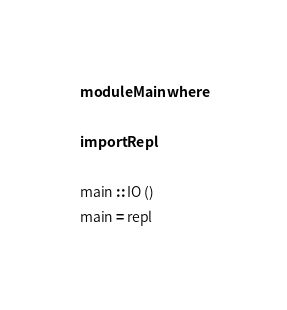Convert code to text. <code><loc_0><loc_0><loc_500><loc_500><_Haskell_>module Main where

import Repl

main :: IO ()
main = repl
</code> 